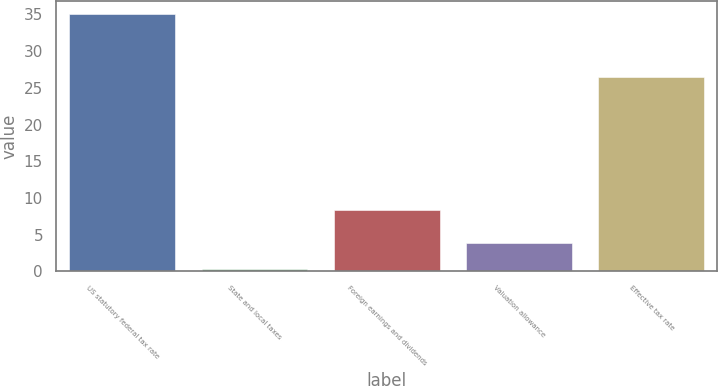<chart> <loc_0><loc_0><loc_500><loc_500><bar_chart><fcel>US statutory federal tax rate<fcel>State and local taxes<fcel>Foreign earnings and dividends<fcel>Valuation allowance<fcel>Effective tax rate<nl><fcel>35<fcel>0.4<fcel>8.3<fcel>3.86<fcel>26.5<nl></chart> 